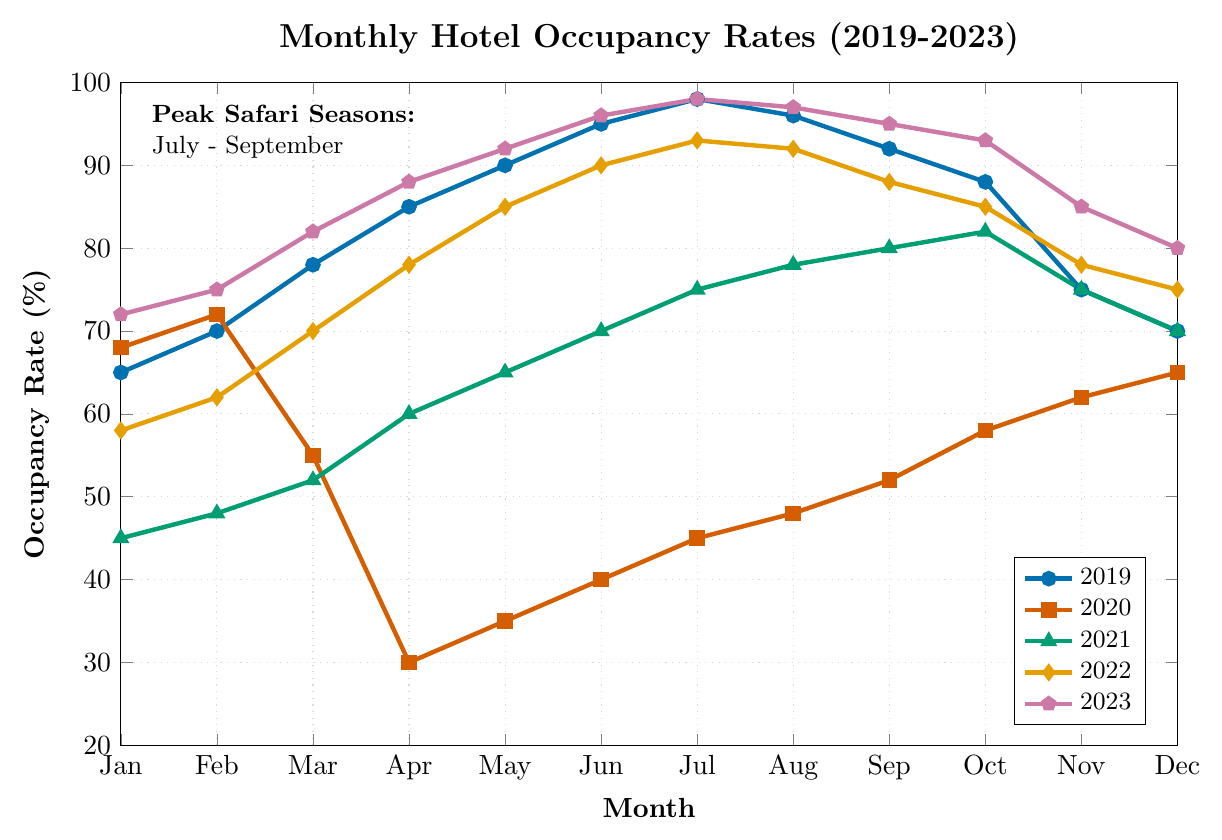What are the peak safari season months according to the figure? The figure highlights July to September as the peak safari seasons. This is indicated directly in a text box within the figure.
Answer: July - September Which year had the highest occupancy rate in July? Look at the data points for July in each year. In 2023, the rate is 98%, which is the highest among all.
Answer: 2023 How did the occupancy rate in February 2020 compare to February 2021? Check the occupancy rates in February for both years. February 2020 had a rate of 72%, while February 2021 had a rate of 48%. So, 2020 had a higher occupancy.
Answer: 2020 What is the average occupancy rate for the month of May over these five years? Sum the May rates and divide by the number of years. (90 + 35 + 65 + 85 + 92) = 367. Divide by 5 = 73.4.
Answer: 73.4 Which month in 2020 had the lowest occupancy rate and what was it? Referring to the 2020 data points, April had the lowest occupancy rate of 30%.
Answer: April, 30% Compare the occupancy rates for September 2021 and October 2021. Which month had a higher rate and by how much? September 2021 had an occupancy rate of 80%, while October 2021 had 82%. October is higher by 2%.
Answer: October, 2% What trend do you observe in occupancy rates from January to July for the year 2019? The occupancy rates show a steady increase from 65% in January to 98% in July.
Answer: Steady increase How did the yearly occupancy rate trend from 2019 to 2023 in June? The data points in June for each year are: 2019 - 95%, 2020 - 40%, 2021 - 70%, 2022 - 90%, 2023 - 96%. The trend shows a dip in 2020 and then a rise again, reaching the highest in 2023.
Answer: Rise with dip in 2020 Which year had the most significant increase in occupancy rate between January and March? Comparing the changes from January to March for each year, 2023 had the highest increase from 72% to 82%, which is a 10% increase.
Answer: 2023 